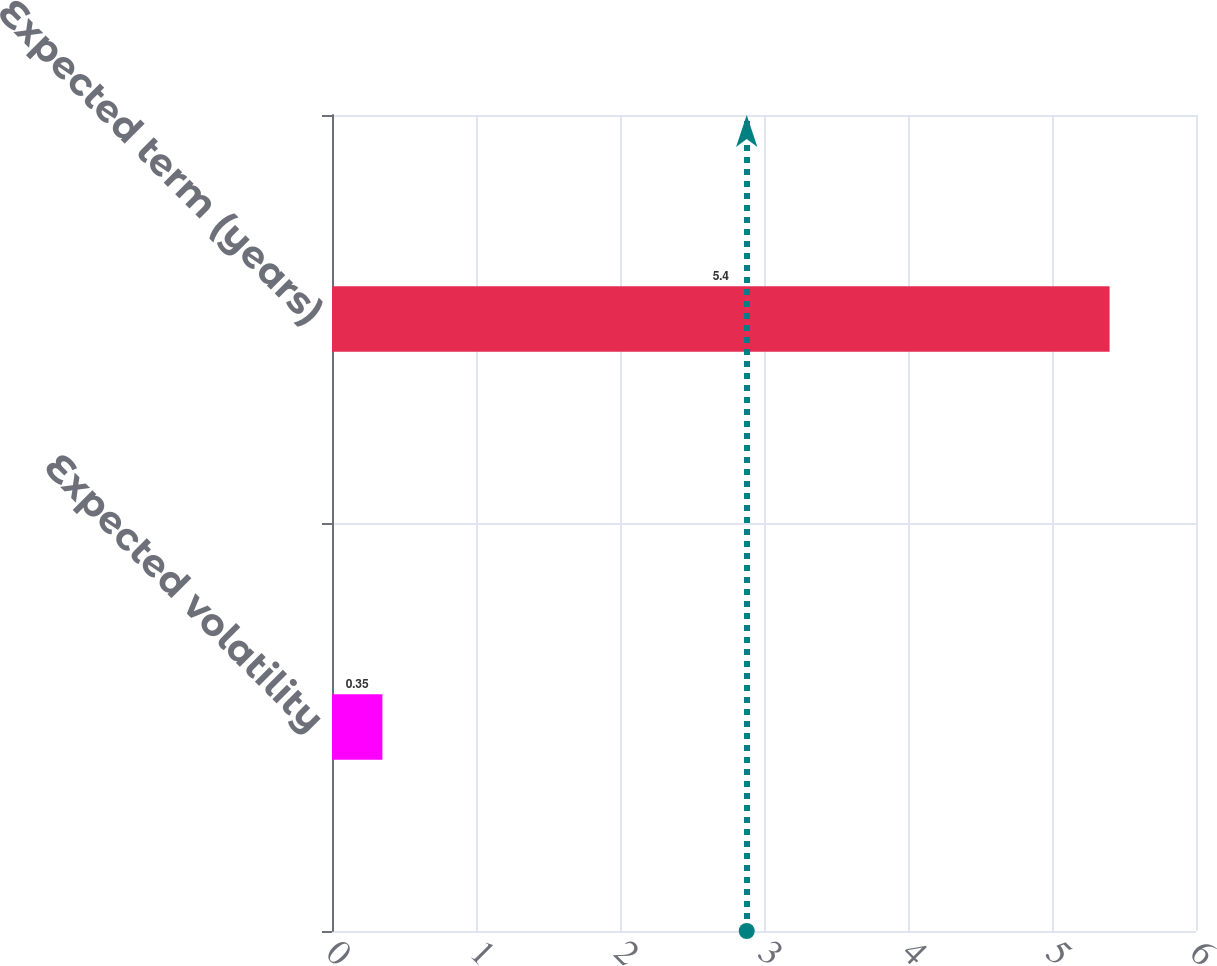Convert chart to OTSL. <chart><loc_0><loc_0><loc_500><loc_500><bar_chart><fcel>Expected volatility<fcel>Expected term (years)<nl><fcel>0.35<fcel>5.4<nl></chart> 